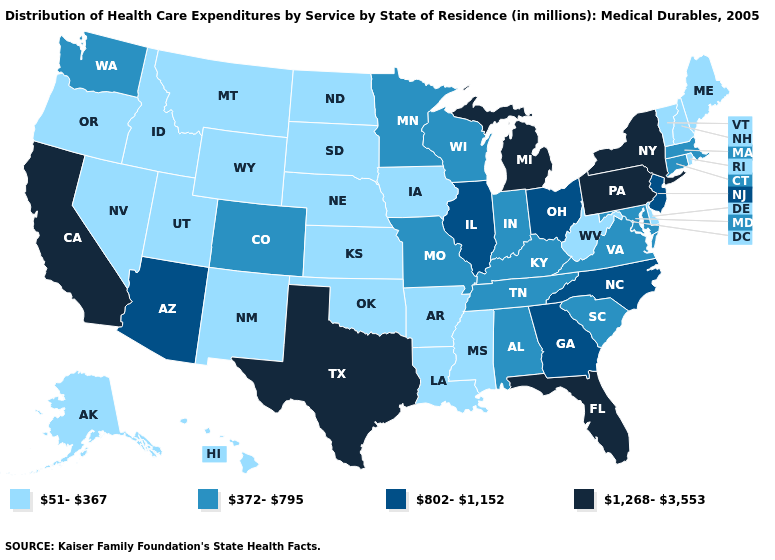What is the highest value in the USA?
Keep it brief. 1,268-3,553. Does New York have the lowest value in the USA?
Quick response, please. No. What is the highest value in states that border Kentucky?
Be succinct. 802-1,152. Name the states that have a value in the range 802-1,152?
Answer briefly. Arizona, Georgia, Illinois, New Jersey, North Carolina, Ohio. Does the first symbol in the legend represent the smallest category?
Keep it brief. Yes. What is the value of Hawaii?
Concise answer only. 51-367. What is the highest value in states that border Kansas?
Give a very brief answer. 372-795. Is the legend a continuous bar?
Be succinct. No. What is the highest value in states that border Virginia?
Be succinct. 802-1,152. What is the value of Massachusetts?
Write a very short answer. 372-795. What is the lowest value in states that border Pennsylvania?
Be succinct. 51-367. Does Delaware have a higher value than Oklahoma?
Concise answer only. No. What is the highest value in the South ?
Short answer required. 1,268-3,553. Which states have the lowest value in the USA?
Concise answer only. Alaska, Arkansas, Delaware, Hawaii, Idaho, Iowa, Kansas, Louisiana, Maine, Mississippi, Montana, Nebraska, Nevada, New Hampshire, New Mexico, North Dakota, Oklahoma, Oregon, Rhode Island, South Dakota, Utah, Vermont, West Virginia, Wyoming. Does New Hampshire have the lowest value in the USA?
Concise answer only. Yes. 